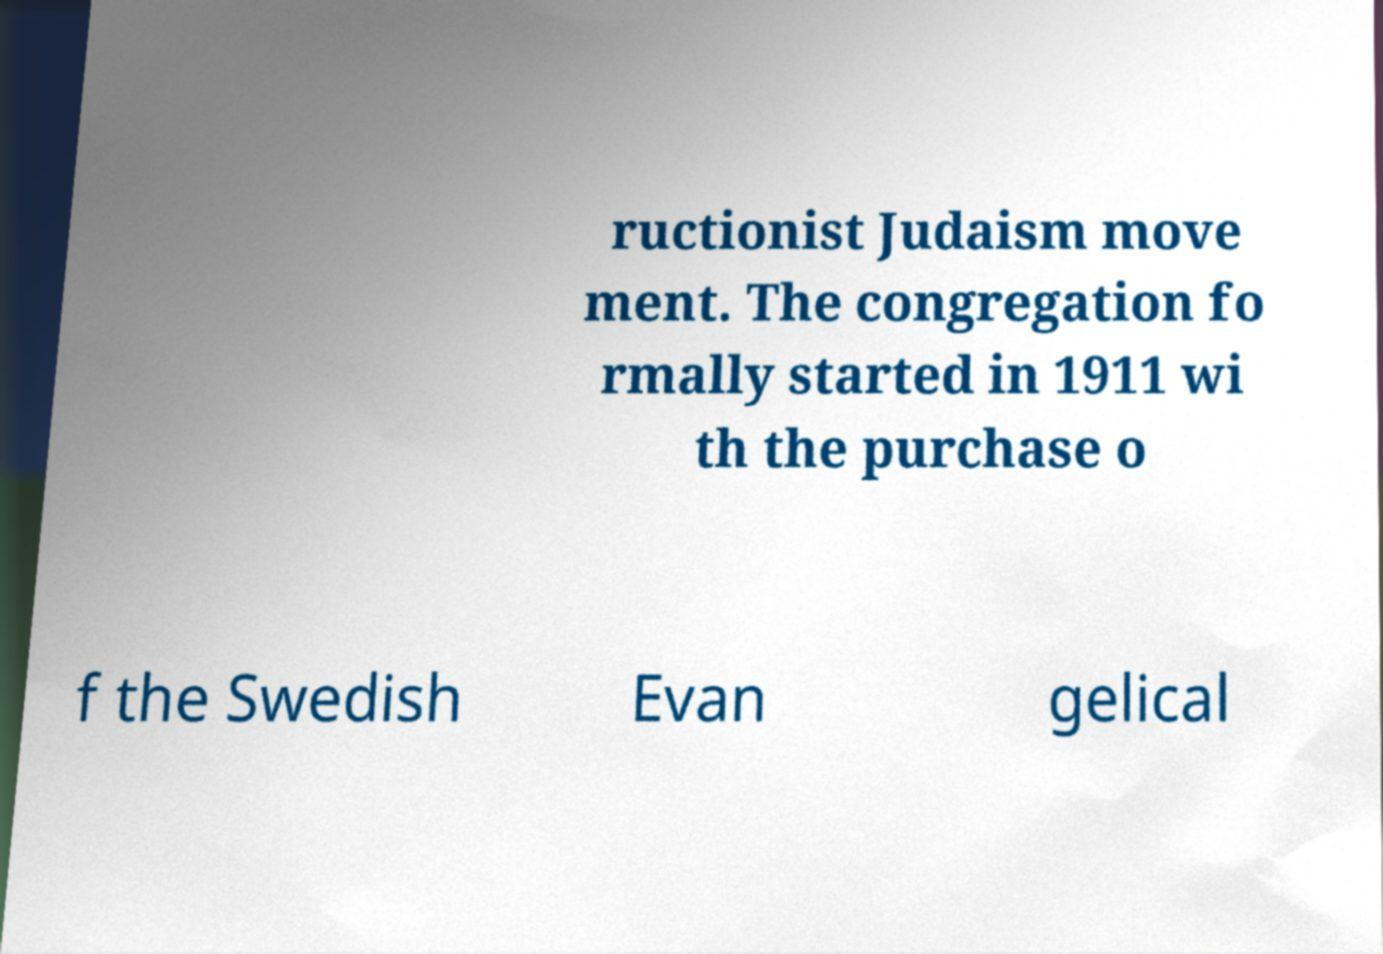Can you accurately transcribe the text from the provided image for me? ructionist Judaism move ment. The congregation fo rmally started in 1911 wi th the purchase o f the Swedish Evan gelical 